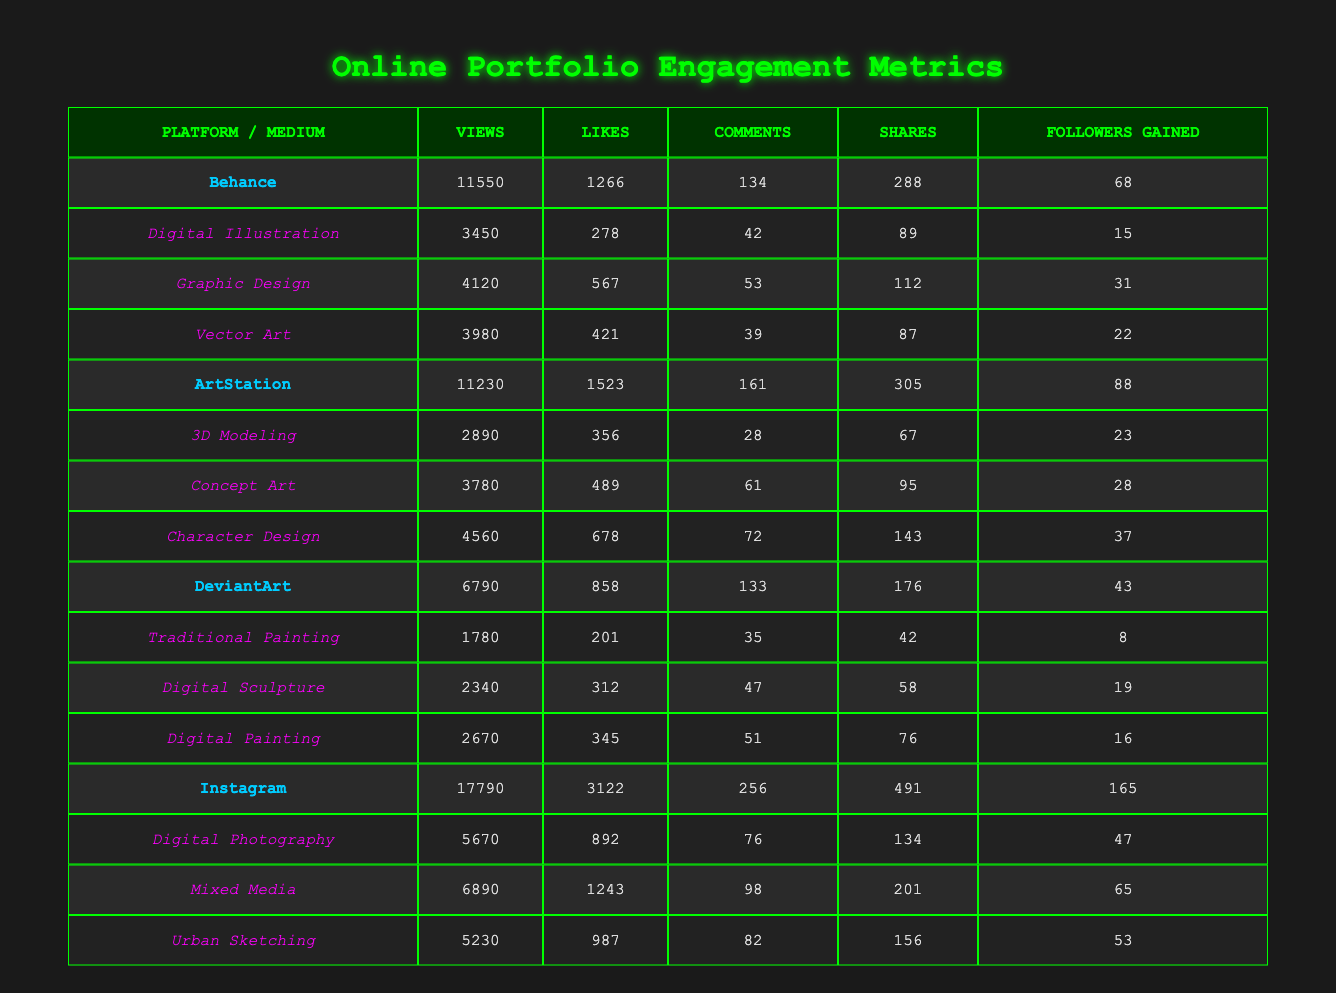What artist received the most likes of any artwork? The table shows the total likes received by each artist across different mediums. The artist with the highest likes is Sophia Lee, with 1243 likes for Mixed Media on Instagram.
Answer: Sophia Lee Which platform had the highest total views? By comparing the total views across each platform, Instagram had the highest total views at 17790.
Answer: Instagram How many more followers were gained by artists on ArtStation compared to DeviantArt? The table indicates that ArtStation artists gained a total of 88 followers, while DeviantArt artists gained 43 followers. The difference is 88 - 43 = 45.
Answer: 45 What is the average number of shares for all artworks under the platform Behance? The total shares for Behance artworks are 288 (for all 3 mediums), comprising 89 + 112 + 87 = 288 shares. There are 3 artworks, so the average is 288 / 3 = 96.
Answer: 96 Did any artist on Instagram gain over 60 followers? By reviewing the follower gain data from Instagram artists, both Sophia Lee and Yuki Tanaka gained 65 and 47 followers respectively. Hence, yes, Sophia Lee gained over 60 followers.
Answer: Yes Which medium on ArtStation received the highest likes? Looking at the likes for each medium in the ArtStation category, Character Design had the highest likes, totaling 678.
Answer: Character Design What is the total view count for all types of artworks on DeviantArt? To find the total views for DeviantArt, we sum the views from Traditional Painting, Digital Sculpture, and Digital Painting: 1780 + 2340 + 2670 = 6790.
Answer: 6790 Which medium had the lowest number of views across all platforms? Examining the views for each medium in the table, Traditional Painting had the lowest views at 1780.
Answer: Traditional Painting 